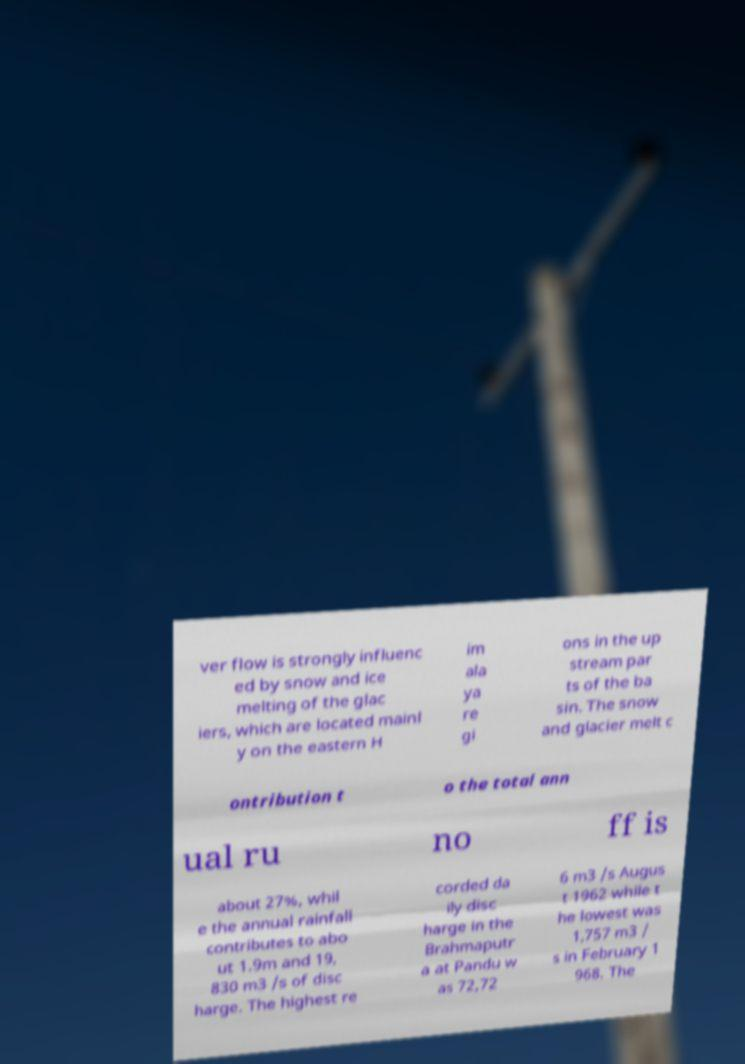Please read and relay the text visible in this image. What does it say? ver flow is strongly influenc ed by snow and ice melting of the glac iers, which are located mainl y on the eastern H im ala ya re gi ons in the up stream par ts of the ba sin. The snow and glacier melt c ontribution t o the total ann ual ru no ff is about 27%, whil e the annual rainfall contributes to abo ut 1.9m and 19, 830 m3 /s of disc harge. The highest re corded da ily disc harge in the Brahmaputr a at Pandu w as 72,72 6 m3 /s Augus t 1962 while t he lowest was 1,757 m3 / s in February 1 968. The 